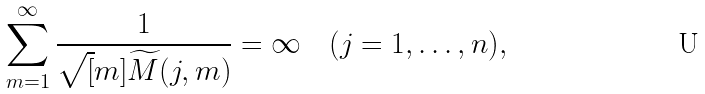<formula> <loc_0><loc_0><loc_500><loc_500>\sum _ { m = 1 } ^ { \infty } \frac { 1 } { \sqrt { [ } m ] { \widetilde { M } ( j , m ) } } = \infty \quad ( j = 1 , \dots , n ) ,</formula> 